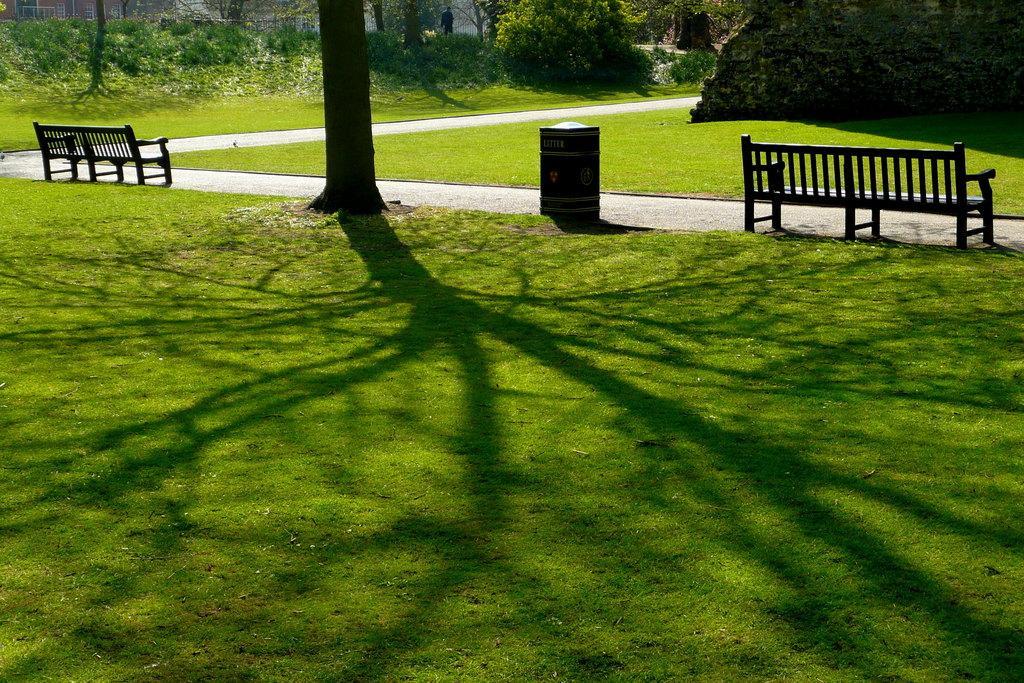Can you describe this image briefly? We can see grass, benches, bin and tree trunk. In the background we can see plants, trees and person. 